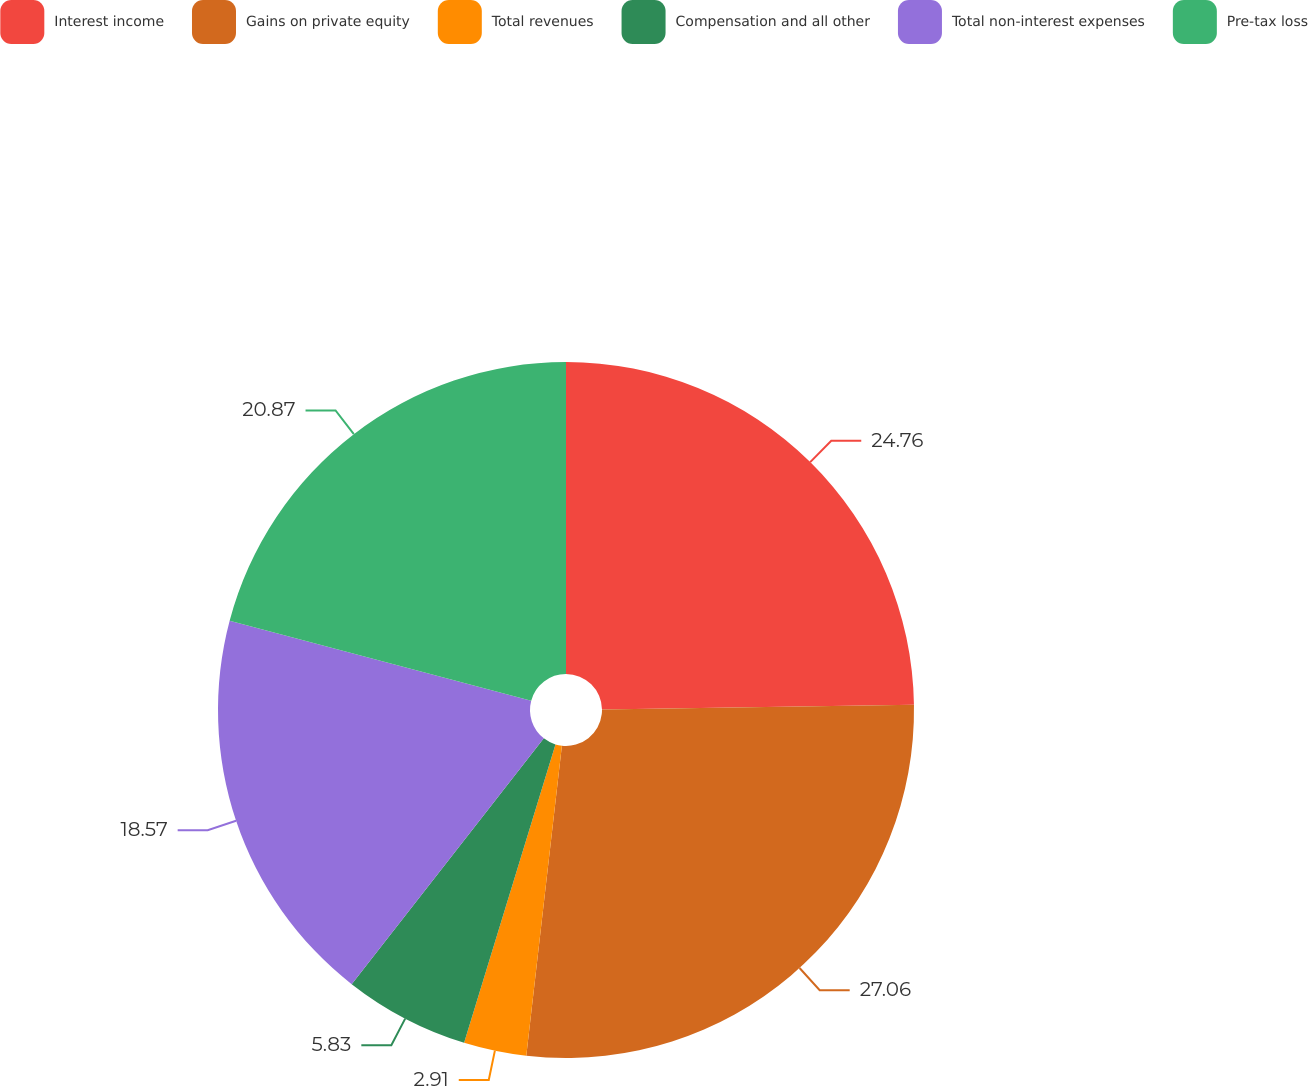Convert chart. <chart><loc_0><loc_0><loc_500><loc_500><pie_chart><fcel>Interest income<fcel>Gains on private equity<fcel>Total revenues<fcel>Compensation and all other<fcel>Total non-interest expenses<fcel>Pre-tax loss<nl><fcel>24.76%<fcel>27.06%<fcel>2.91%<fcel>5.83%<fcel>18.57%<fcel>20.87%<nl></chart> 